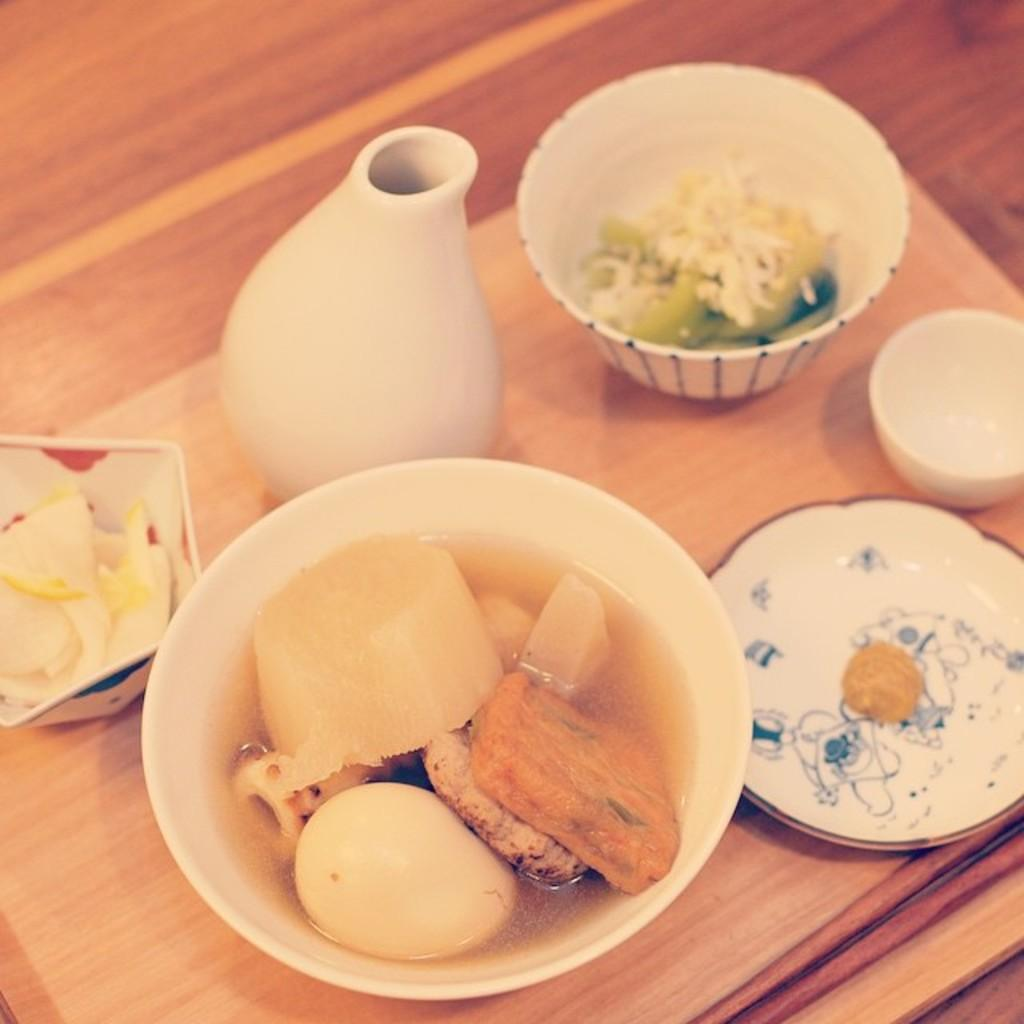What piece of furniture is present in the image? There is a table in the image. What is placed on the table? There are bowls and a saucer on the table. What is inside the bowls? There is food in the bowls. Where is the river flowing in the image? There is no river present in the image. What type of throne can be seen in the image? There is no throne present in the image. 